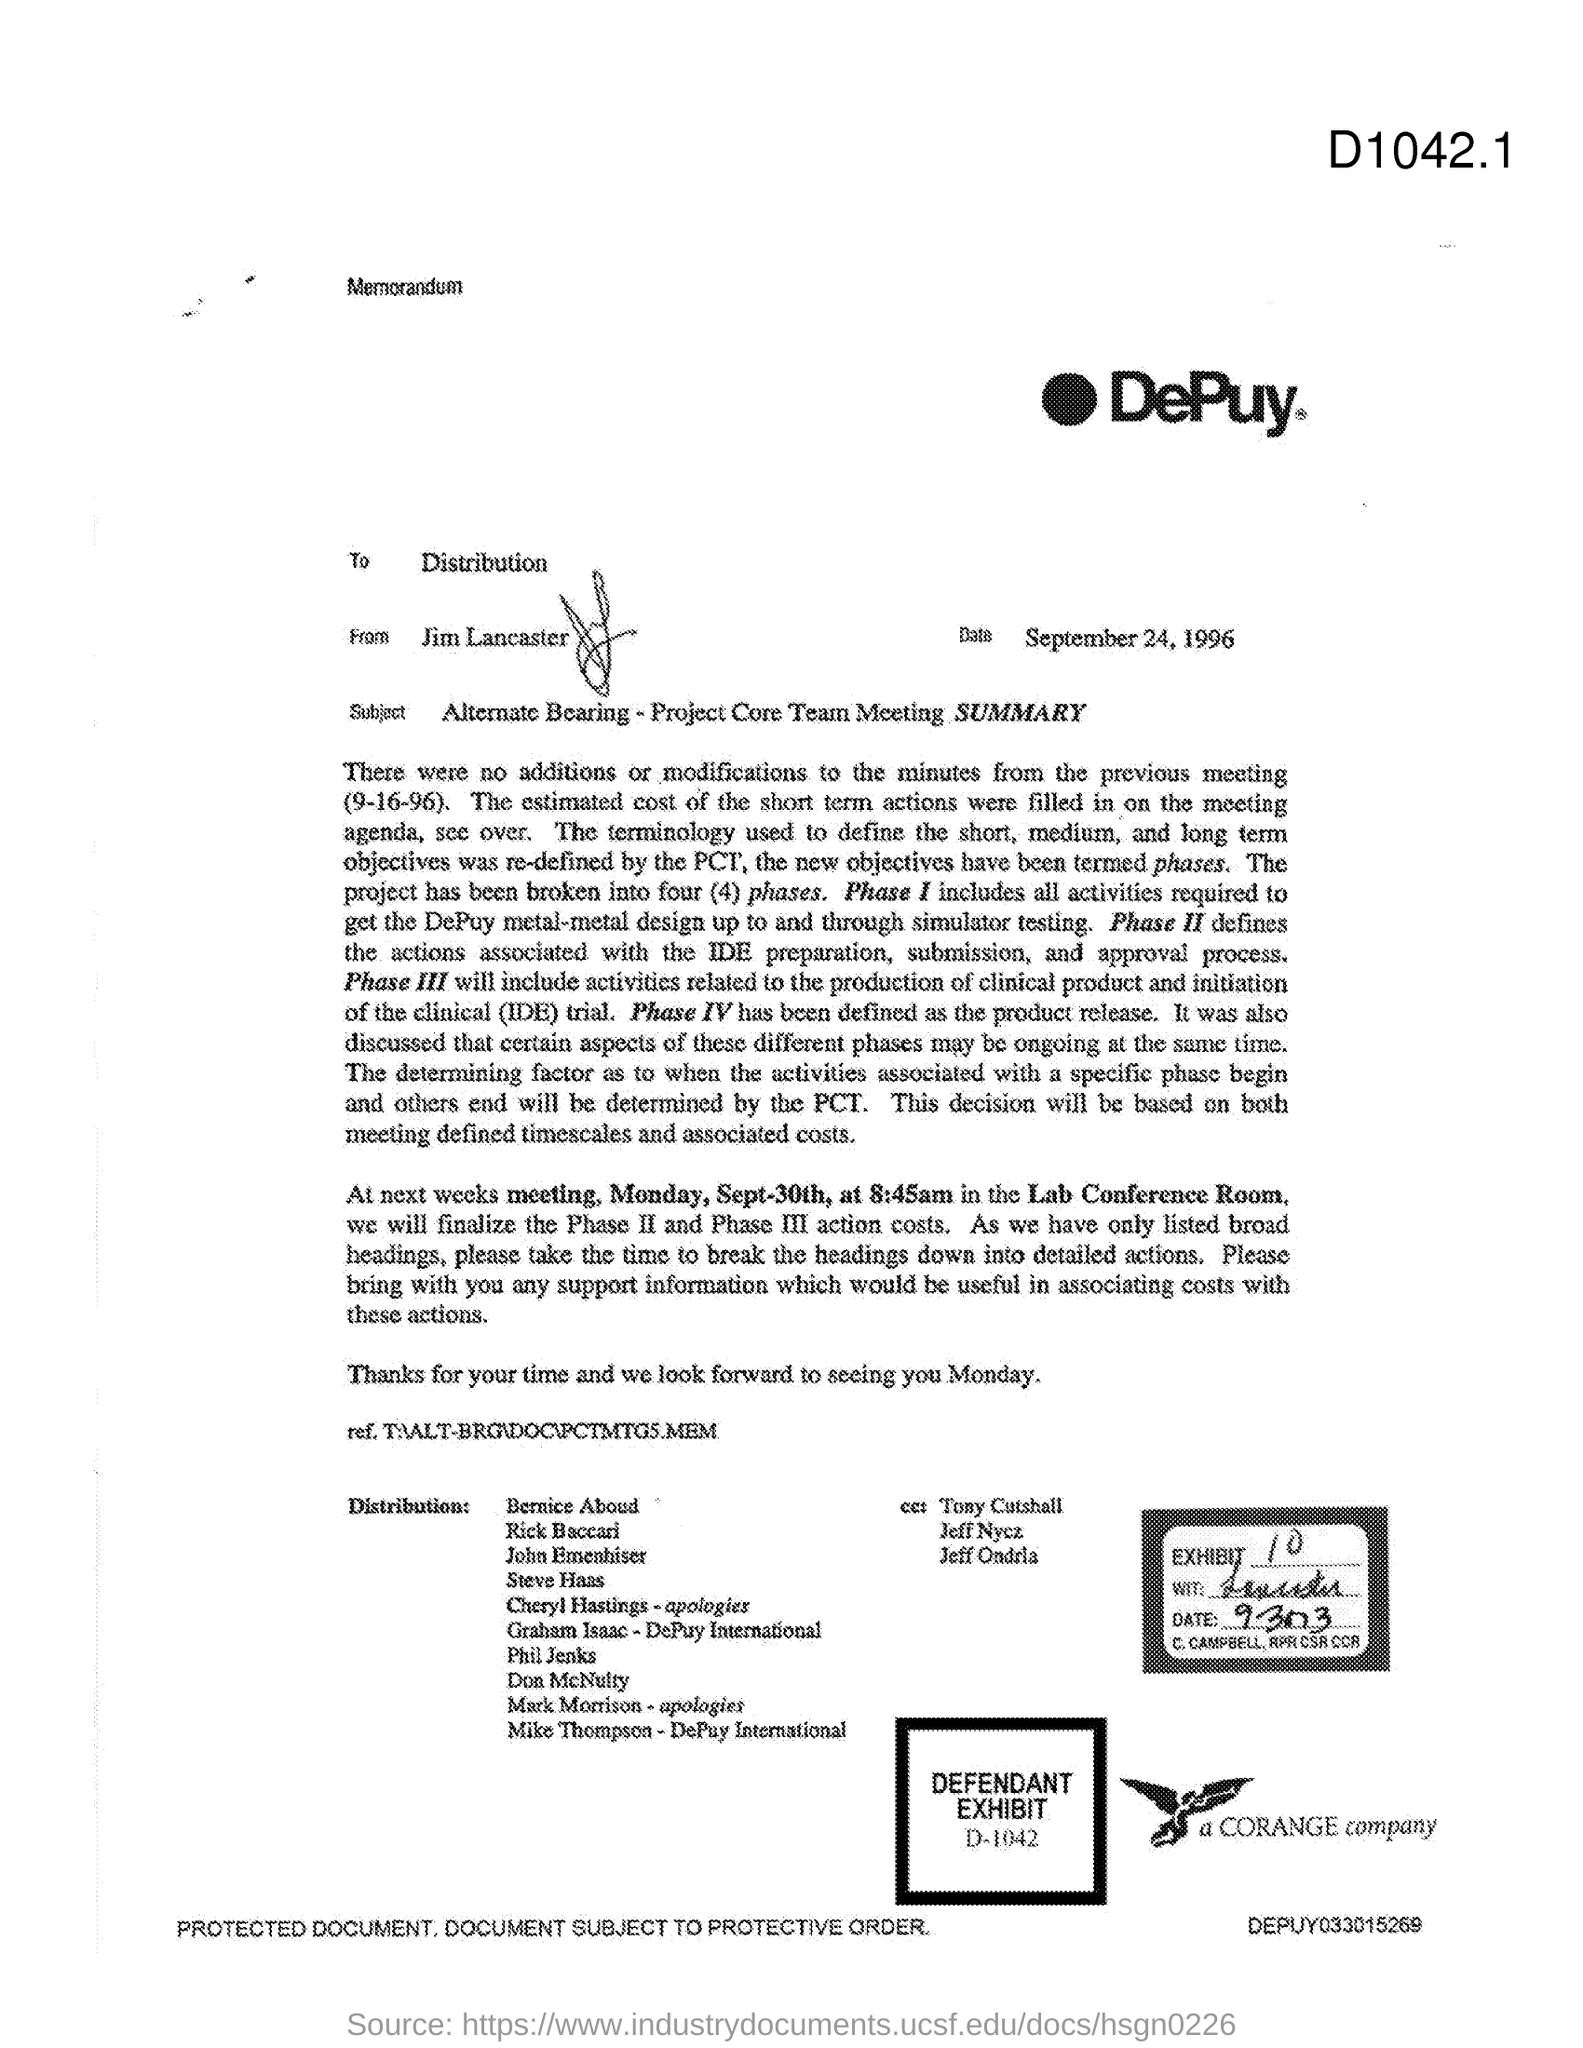Point out several critical features in this image. The memorandum is from Jim Lancaster. The date is September 24, 1996. The next meeting will be held in the lab conference room. The memorandum is addressed to the distribution list. 